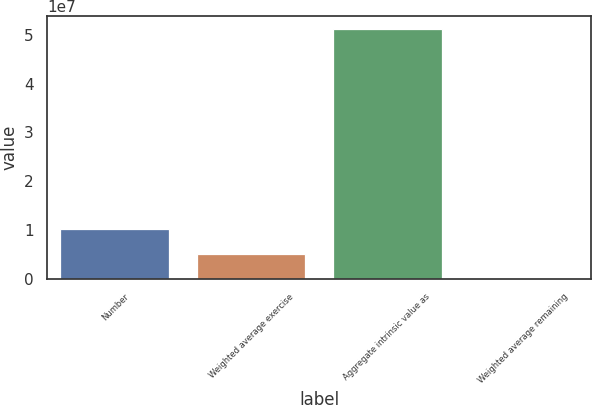Convert chart. <chart><loc_0><loc_0><loc_500><loc_500><bar_chart><fcel>Number<fcel>Weighted average exercise<fcel>Aggregate intrinsic value as<fcel>Weighted average remaining<nl><fcel>1.02388e+07<fcel>5.11939e+06<fcel>5.11939e+07<fcel>2.1<nl></chart> 